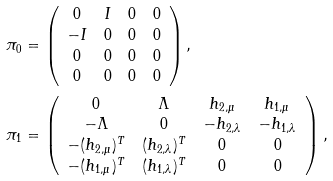Convert formula to latex. <formula><loc_0><loc_0><loc_500><loc_500>& \pi _ { 0 } = \left ( \begin{array} { c c c c } 0 & I & 0 & 0 \\ - I & 0 & 0 & 0 \\ 0 & 0 & 0 & 0 \\ 0 & 0 & 0 & 0 \end{array} \right ) , \\ & \pi _ { 1 } = \left ( \begin{array} { c c c c } 0 & \Lambda & h _ { 2 , \mu } & h _ { 1 , \mu } \\ - \Lambda & 0 & - h _ { 2 , \lambda } & - h _ { 1 , \lambda } \\ - ( h _ { 2 , \mu } ) ^ { T } & ( h _ { 2 , \lambda } ) ^ { T } & 0 & 0 \\ - ( h _ { 1 , \mu } ) ^ { T } & ( h _ { 1 , \lambda } ) ^ { T } & 0 & 0 \end{array} \right ) ,</formula> 